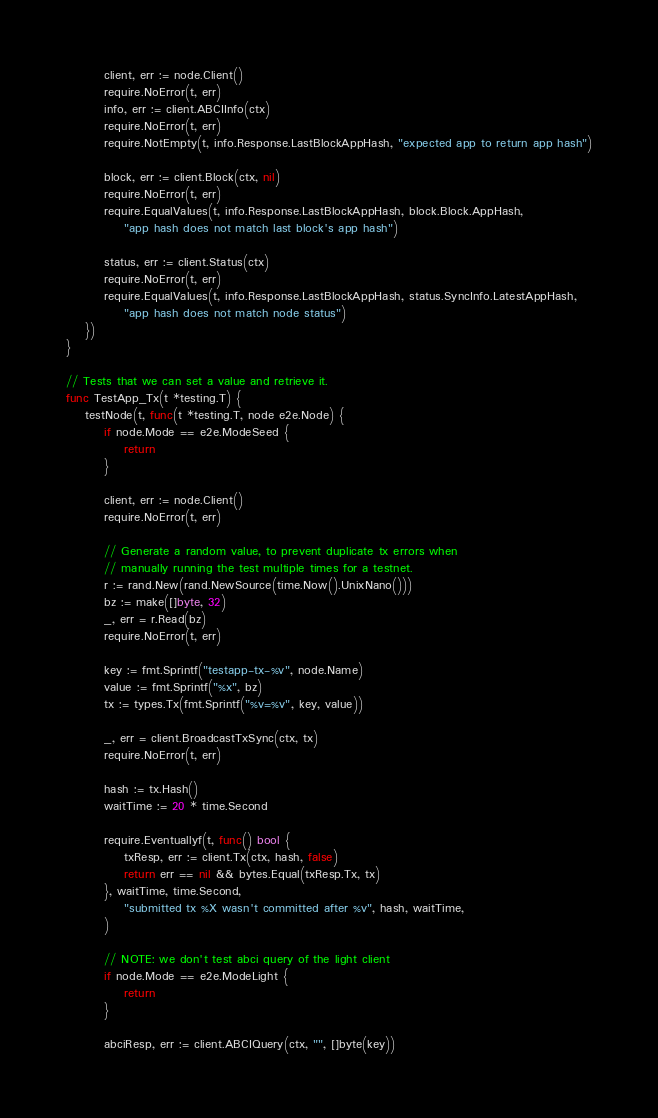Convert code to text. <code><loc_0><loc_0><loc_500><loc_500><_Go_>		client, err := node.Client()
		require.NoError(t, err)
		info, err := client.ABCIInfo(ctx)
		require.NoError(t, err)
		require.NotEmpty(t, info.Response.LastBlockAppHash, "expected app to return app hash")

		block, err := client.Block(ctx, nil)
		require.NoError(t, err)
		require.EqualValues(t, info.Response.LastBlockAppHash, block.Block.AppHash,
			"app hash does not match last block's app hash")

		status, err := client.Status(ctx)
		require.NoError(t, err)
		require.EqualValues(t, info.Response.LastBlockAppHash, status.SyncInfo.LatestAppHash,
			"app hash does not match node status")
	})
}

// Tests that we can set a value and retrieve it.
func TestApp_Tx(t *testing.T) {
	testNode(t, func(t *testing.T, node e2e.Node) {
		if node.Mode == e2e.ModeSeed {
			return
		}

		client, err := node.Client()
		require.NoError(t, err)

		// Generate a random value, to prevent duplicate tx errors when
		// manually running the test multiple times for a testnet.
		r := rand.New(rand.NewSource(time.Now().UnixNano()))
		bz := make([]byte, 32)
		_, err = r.Read(bz)
		require.NoError(t, err)

		key := fmt.Sprintf("testapp-tx-%v", node.Name)
		value := fmt.Sprintf("%x", bz)
		tx := types.Tx(fmt.Sprintf("%v=%v", key, value))

		_, err = client.BroadcastTxSync(ctx, tx)
		require.NoError(t, err)

		hash := tx.Hash()
		waitTime := 20 * time.Second

		require.Eventuallyf(t, func() bool {
			txResp, err := client.Tx(ctx, hash, false)
			return err == nil && bytes.Equal(txResp.Tx, tx)
		}, waitTime, time.Second,
			"submitted tx %X wasn't committed after %v", hash, waitTime,
		)

		// NOTE: we don't test abci query of the light client
		if node.Mode == e2e.ModeLight {
			return
		}

		abciResp, err := client.ABCIQuery(ctx, "", []byte(key))</code> 